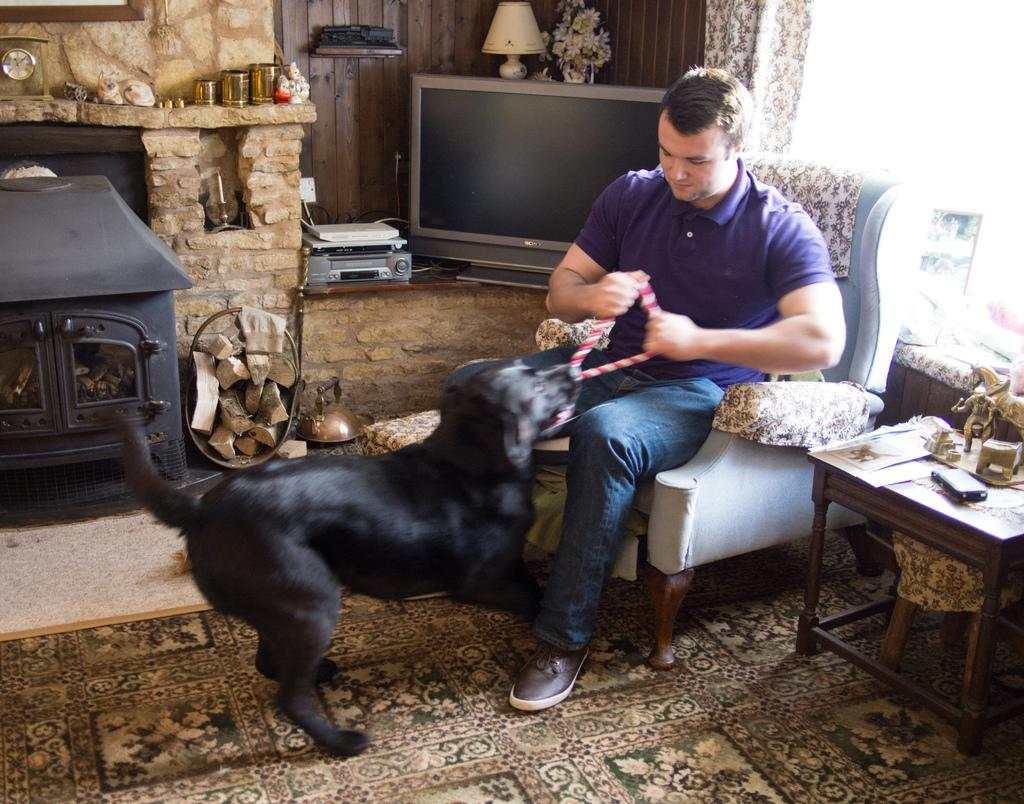Who is present in the image? There is a man in the image. What is the man doing in the image? The man is holding the belt of a black-colored dog. What electronic device can be seen in the image? There is a TV in the image. What is placed on top of the TV? There is a lamp on top of the TV. What piece of furniture is visible in the image? There is a table in the image. What type of drum is the man playing in the image? There is no drum present in the image; the man is holding the belt of a black-colored dog. 